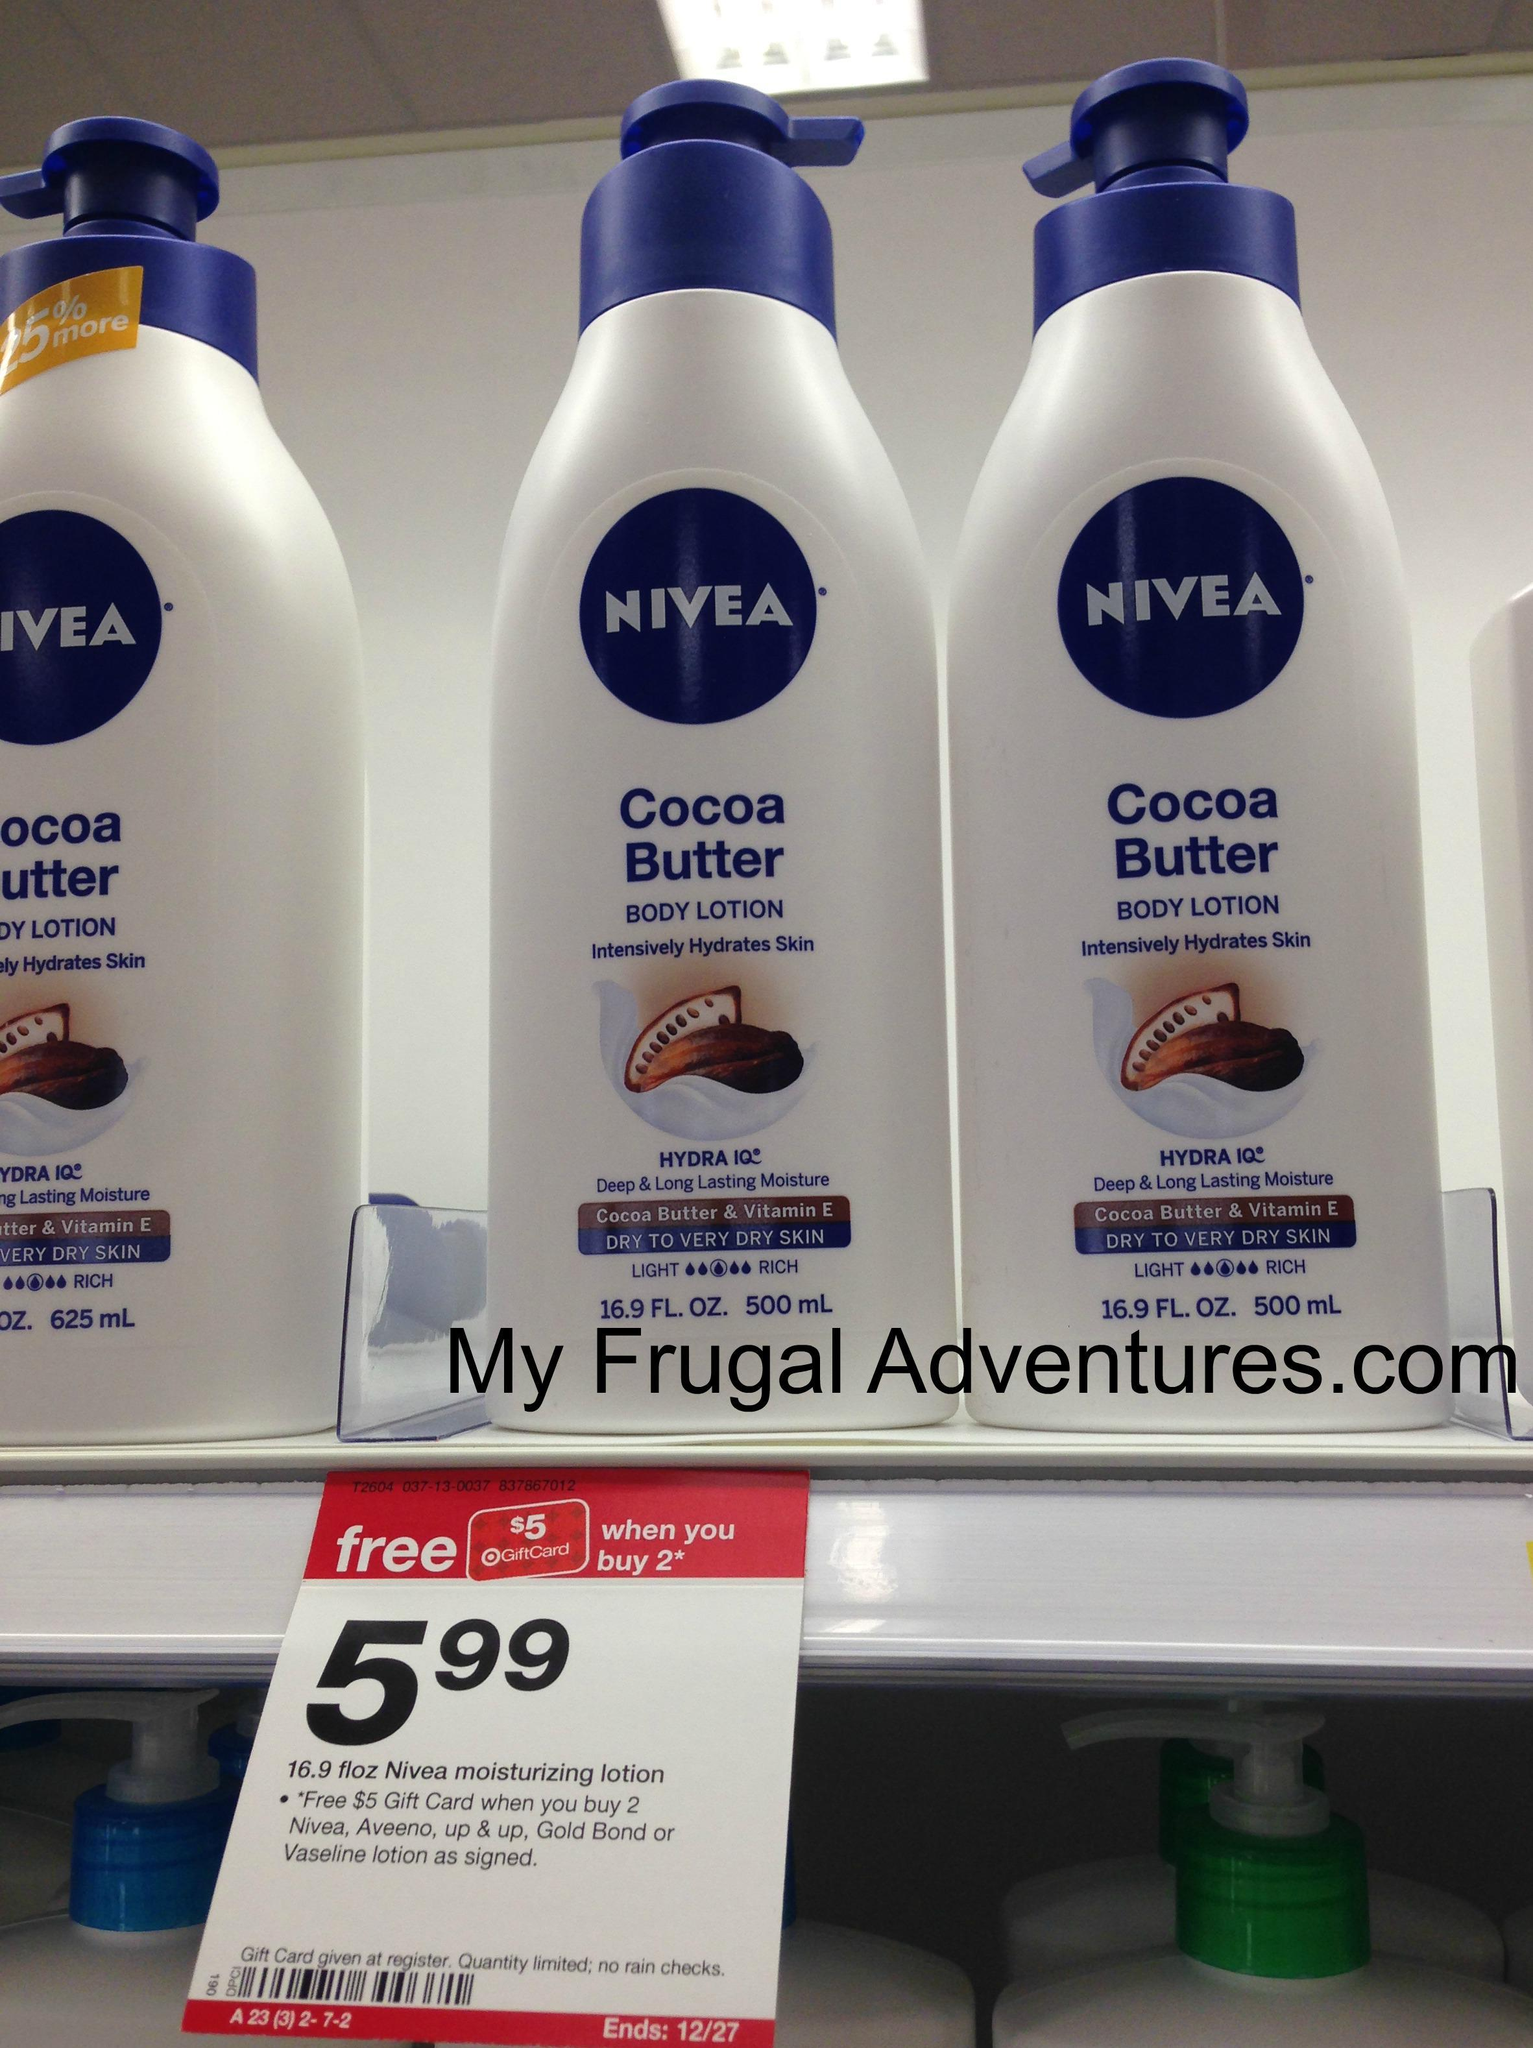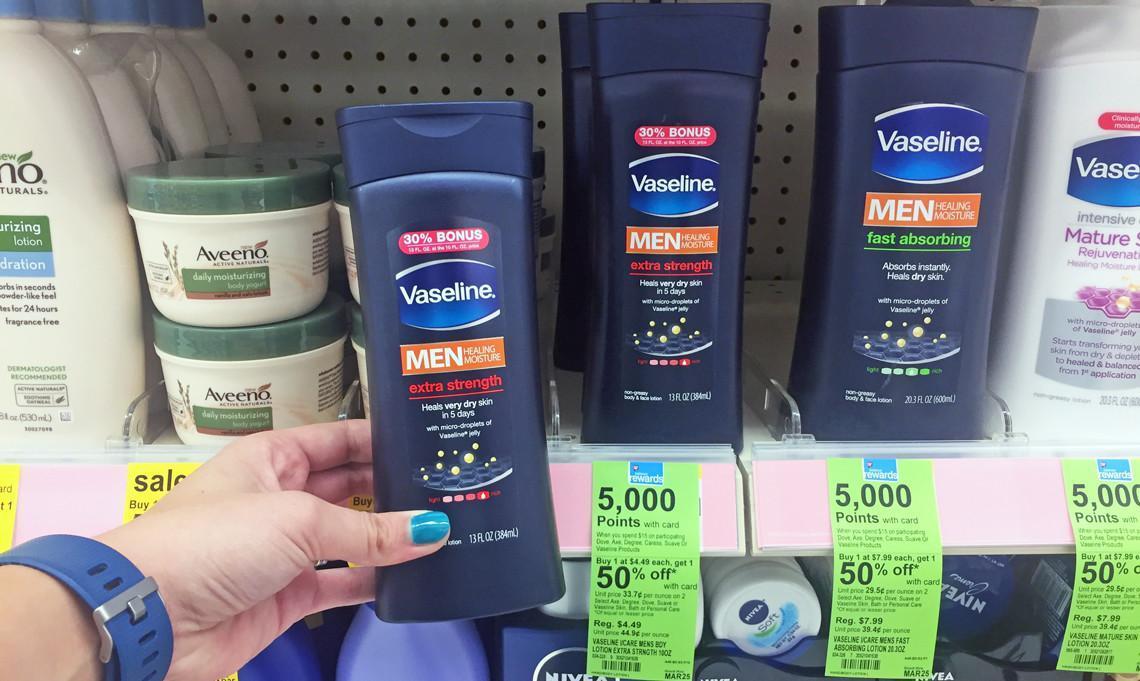The first image is the image on the left, the second image is the image on the right. Examine the images to the left and right. Is the description "There is a hand holding product next to the shelf that shows the sales prices, on the wrist is a watch" accurate? Answer yes or no. Yes. The first image is the image on the left, the second image is the image on the right. Analyze the images presented: Is the assertion "Some price tags are green." valid? Answer yes or no. Yes. 